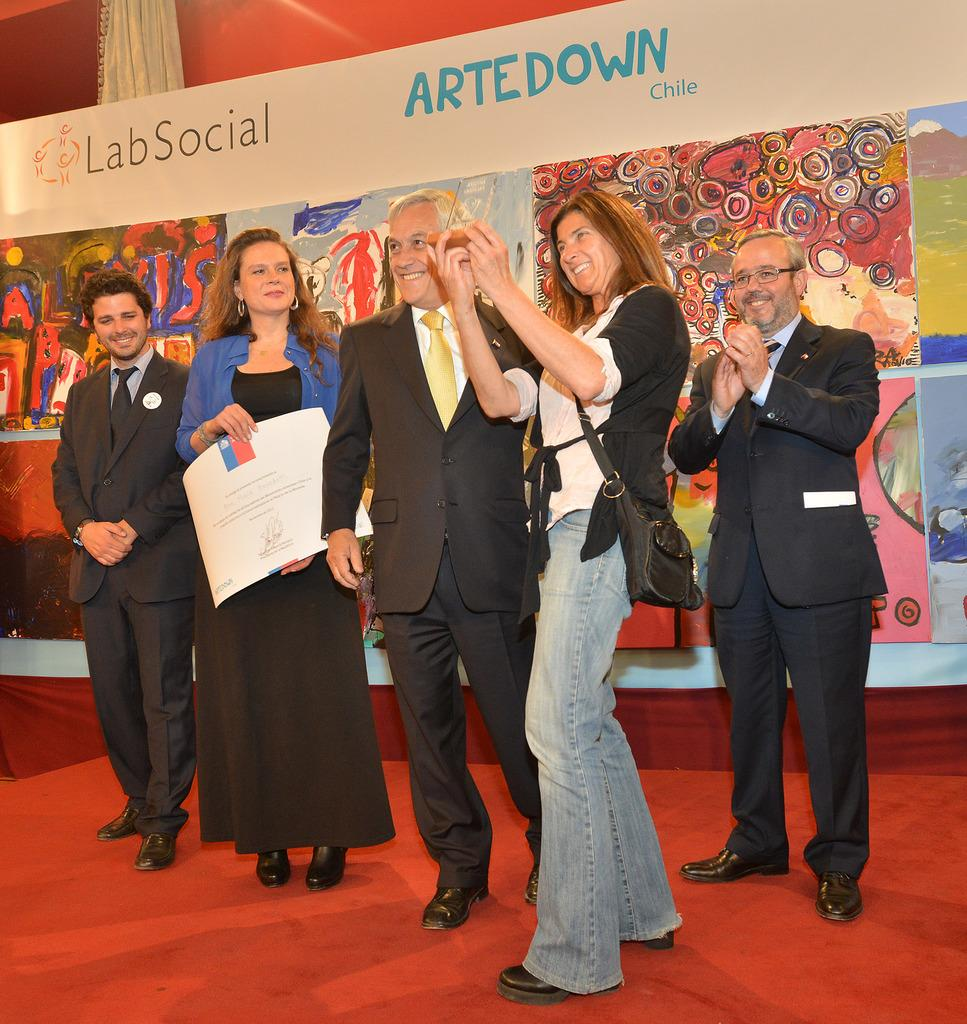What is the color of the floor in the image? The floor in the image is red. What are the persons in the image doing? The persons are standing and smiling. What can be seen in the background of the image? There is a huge banner in the background of the image. What type of spy apparatus can be seen in the image? There is no spy apparatus present in the image. What color is the spot on the floor in the image? There is no spot on the floor in the image; the floor is uniformly red. 